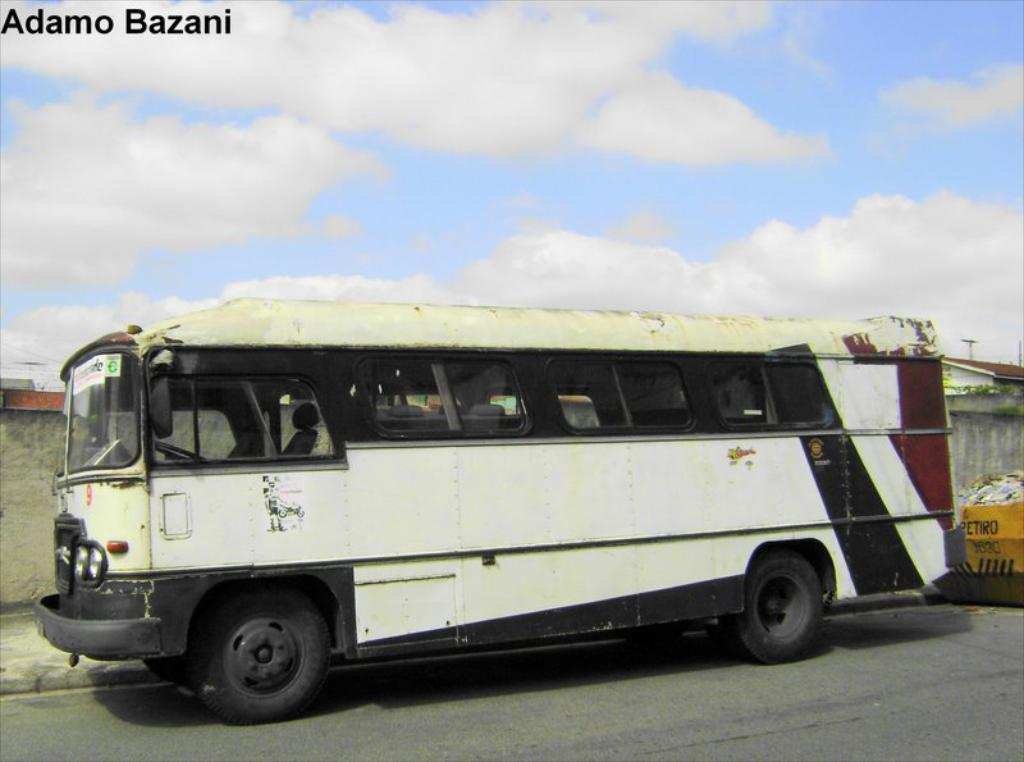What is the main subject in the middle of the image? There is a bus in the middle of the image. What is located at the bottom of the image? There is a road at the bottom of the image. What can be seen in the background of the image? There are houses, a wall, garbage, and the sky visible in the background of the image. What is the condition of the sky in the image? The sky is visible in the background of the image, and there are clouds present. Is there any text present in the image? Yes, there is text present in the image. How many cattle can be seen grazing in the image? There are no cattle present in the image. 